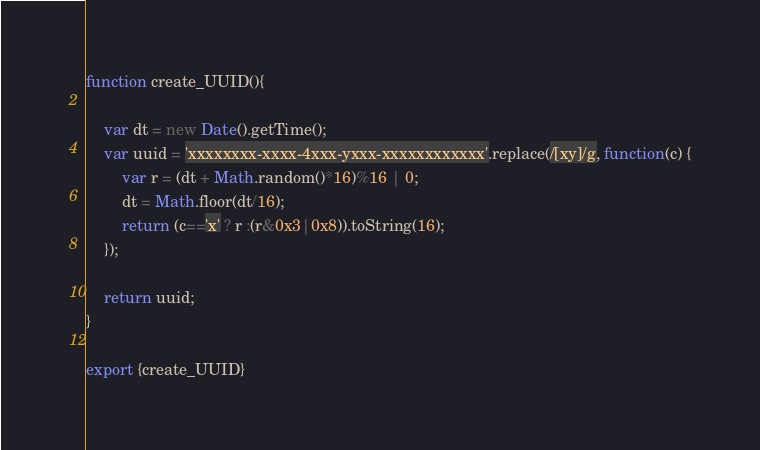<code> <loc_0><loc_0><loc_500><loc_500><_JavaScript_>
function create_UUID(){

    var dt = new Date().getTime();
    var uuid = 'xxxxxxxx-xxxx-4xxx-yxxx-xxxxxxxxxxxx'.replace(/[xy]/g, function(c) {
        var r = (dt + Math.random()*16)%16 | 0;
        dt = Math.floor(dt/16);
        return (c=='x' ? r :(r&0x3|0x8)).toString(16);
    });
    
    return uuid;
}

export {create_UUID}</code> 